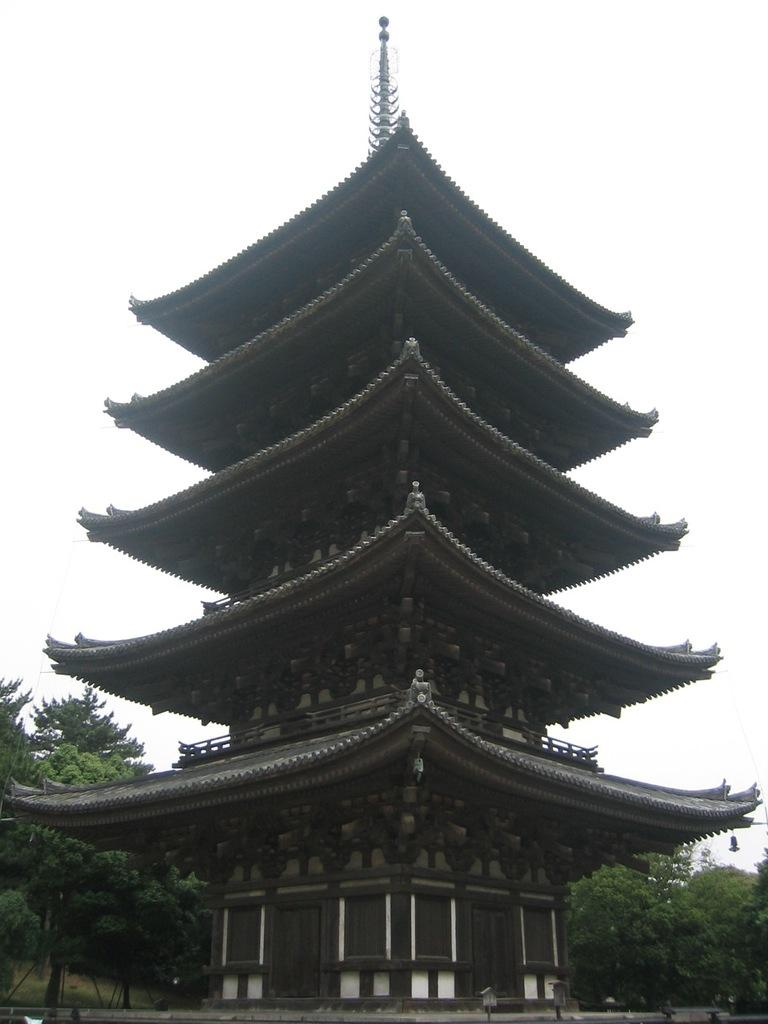What type of construction is depicted in the image? There is a Chinese construction in the picture. What can be seen behind the construction? Trees are visible behind the Chinese construction. What is visible in the background of the image? The sky is visible in the background of the picture. Where is the library located in the image? There is no library present in the image; it features a Chinese construction. What type of dirt can be seen on the ground in the image? There is no dirt visible in the image; the ground is not described in the provided facts. 